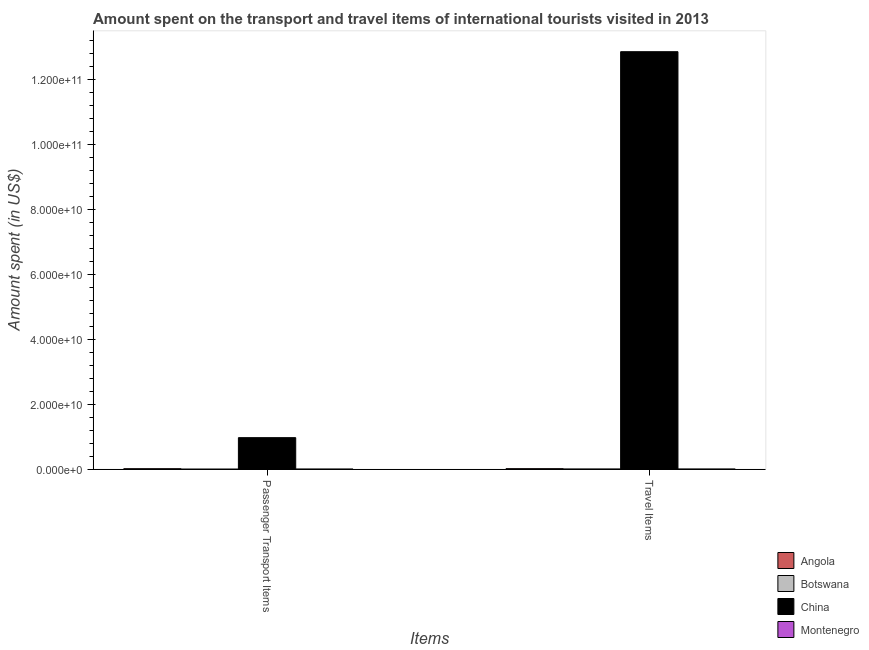How many different coloured bars are there?
Your answer should be compact. 4. Are the number of bars per tick equal to the number of legend labels?
Offer a very short reply. Yes. What is the label of the 2nd group of bars from the left?
Provide a short and direct response. Travel Items. What is the amount spent on passenger transport items in China?
Your response must be concise. 9.72e+09. Across all countries, what is the maximum amount spent on passenger transport items?
Offer a very short reply. 9.72e+09. Across all countries, what is the minimum amount spent in travel items?
Offer a terse response. 4.70e+07. In which country was the amount spent on passenger transport items minimum?
Your answer should be compact. Botswana. What is the total amount spent in travel items in the graph?
Your answer should be very brief. 1.29e+11. What is the difference between the amount spent on passenger transport items in China and that in Angola?
Give a very brief answer. 9.57e+09. What is the difference between the amount spent on passenger transport items in Montenegro and the amount spent in travel items in China?
Your answer should be compact. -1.29e+11. What is the average amount spent on passenger transport items per country?
Give a very brief answer. 2.48e+09. What is the difference between the amount spent on passenger transport items and amount spent in travel items in China?
Your answer should be very brief. -1.19e+11. What is the ratio of the amount spent on passenger transport items in China to that in Botswana?
Offer a terse response. 4.86e+04. Is the amount spent on passenger transport items in Botswana less than that in Montenegro?
Provide a short and direct response. Yes. What does the 4th bar from the left in Travel Items represents?
Your answer should be very brief. Montenegro. What does the 1st bar from the right in Passenger Transport Items represents?
Your response must be concise. Montenegro. How many bars are there?
Your answer should be compact. 8. Are all the bars in the graph horizontal?
Ensure brevity in your answer.  No. What is the difference between two consecutive major ticks on the Y-axis?
Provide a succinct answer. 2.00e+1. Does the graph contain any zero values?
Provide a short and direct response. No. How are the legend labels stacked?
Provide a short and direct response. Vertical. What is the title of the graph?
Your answer should be very brief. Amount spent on the transport and travel items of international tourists visited in 2013. What is the label or title of the X-axis?
Ensure brevity in your answer.  Items. What is the label or title of the Y-axis?
Give a very brief answer. Amount spent (in US$). What is the Amount spent (in US$) in Angola in Passenger Transport Items?
Your answer should be compact. 1.53e+08. What is the Amount spent (in US$) of Botswana in Passenger Transport Items?
Offer a terse response. 2.00e+05. What is the Amount spent (in US$) in China in Passenger Transport Items?
Your response must be concise. 9.72e+09. What is the Amount spent (in US$) in Montenegro in Passenger Transport Items?
Ensure brevity in your answer.  3.30e+07. What is the Amount spent (in US$) of Angola in Travel Items?
Make the answer very short. 1.66e+08. What is the Amount spent (in US$) in Botswana in Travel Items?
Offer a terse response. 4.70e+07. What is the Amount spent (in US$) in China in Travel Items?
Offer a terse response. 1.29e+11. What is the Amount spent (in US$) in Montenegro in Travel Items?
Keep it short and to the point. 4.80e+07. Across all Items, what is the maximum Amount spent (in US$) in Angola?
Your answer should be compact. 1.66e+08. Across all Items, what is the maximum Amount spent (in US$) in Botswana?
Give a very brief answer. 4.70e+07. Across all Items, what is the maximum Amount spent (in US$) in China?
Offer a very short reply. 1.29e+11. Across all Items, what is the maximum Amount spent (in US$) in Montenegro?
Provide a succinct answer. 4.80e+07. Across all Items, what is the minimum Amount spent (in US$) of Angola?
Ensure brevity in your answer.  1.53e+08. Across all Items, what is the minimum Amount spent (in US$) of Botswana?
Provide a short and direct response. 2.00e+05. Across all Items, what is the minimum Amount spent (in US$) in China?
Offer a terse response. 9.72e+09. Across all Items, what is the minimum Amount spent (in US$) in Montenegro?
Keep it short and to the point. 3.30e+07. What is the total Amount spent (in US$) of Angola in the graph?
Give a very brief answer. 3.19e+08. What is the total Amount spent (in US$) in Botswana in the graph?
Offer a very short reply. 4.72e+07. What is the total Amount spent (in US$) of China in the graph?
Give a very brief answer. 1.38e+11. What is the total Amount spent (in US$) of Montenegro in the graph?
Provide a succinct answer. 8.10e+07. What is the difference between the Amount spent (in US$) of Angola in Passenger Transport Items and that in Travel Items?
Offer a very short reply. -1.30e+07. What is the difference between the Amount spent (in US$) in Botswana in Passenger Transport Items and that in Travel Items?
Keep it short and to the point. -4.68e+07. What is the difference between the Amount spent (in US$) of China in Passenger Transport Items and that in Travel Items?
Ensure brevity in your answer.  -1.19e+11. What is the difference between the Amount spent (in US$) of Montenegro in Passenger Transport Items and that in Travel Items?
Offer a terse response. -1.50e+07. What is the difference between the Amount spent (in US$) in Angola in Passenger Transport Items and the Amount spent (in US$) in Botswana in Travel Items?
Give a very brief answer. 1.06e+08. What is the difference between the Amount spent (in US$) of Angola in Passenger Transport Items and the Amount spent (in US$) of China in Travel Items?
Make the answer very short. -1.28e+11. What is the difference between the Amount spent (in US$) of Angola in Passenger Transport Items and the Amount spent (in US$) of Montenegro in Travel Items?
Offer a very short reply. 1.05e+08. What is the difference between the Amount spent (in US$) of Botswana in Passenger Transport Items and the Amount spent (in US$) of China in Travel Items?
Ensure brevity in your answer.  -1.29e+11. What is the difference between the Amount spent (in US$) of Botswana in Passenger Transport Items and the Amount spent (in US$) of Montenegro in Travel Items?
Offer a very short reply. -4.78e+07. What is the difference between the Amount spent (in US$) of China in Passenger Transport Items and the Amount spent (in US$) of Montenegro in Travel Items?
Your response must be concise. 9.67e+09. What is the average Amount spent (in US$) of Angola per Items?
Your response must be concise. 1.60e+08. What is the average Amount spent (in US$) in Botswana per Items?
Offer a very short reply. 2.36e+07. What is the average Amount spent (in US$) in China per Items?
Make the answer very short. 6.91e+1. What is the average Amount spent (in US$) in Montenegro per Items?
Offer a terse response. 4.05e+07. What is the difference between the Amount spent (in US$) of Angola and Amount spent (in US$) of Botswana in Passenger Transport Items?
Offer a terse response. 1.53e+08. What is the difference between the Amount spent (in US$) of Angola and Amount spent (in US$) of China in Passenger Transport Items?
Ensure brevity in your answer.  -9.57e+09. What is the difference between the Amount spent (in US$) in Angola and Amount spent (in US$) in Montenegro in Passenger Transport Items?
Offer a very short reply. 1.20e+08. What is the difference between the Amount spent (in US$) in Botswana and Amount spent (in US$) in China in Passenger Transport Items?
Provide a succinct answer. -9.72e+09. What is the difference between the Amount spent (in US$) of Botswana and Amount spent (in US$) of Montenegro in Passenger Transport Items?
Give a very brief answer. -3.28e+07. What is the difference between the Amount spent (in US$) of China and Amount spent (in US$) of Montenegro in Passenger Transport Items?
Provide a succinct answer. 9.69e+09. What is the difference between the Amount spent (in US$) of Angola and Amount spent (in US$) of Botswana in Travel Items?
Offer a terse response. 1.19e+08. What is the difference between the Amount spent (in US$) in Angola and Amount spent (in US$) in China in Travel Items?
Provide a succinct answer. -1.28e+11. What is the difference between the Amount spent (in US$) of Angola and Amount spent (in US$) of Montenegro in Travel Items?
Your answer should be compact. 1.18e+08. What is the difference between the Amount spent (in US$) in Botswana and Amount spent (in US$) in China in Travel Items?
Make the answer very short. -1.29e+11. What is the difference between the Amount spent (in US$) in China and Amount spent (in US$) in Montenegro in Travel Items?
Provide a short and direct response. 1.29e+11. What is the ratio of the Amount spent (in US$) in Angola in Passenger Transport Items to that in Travel Items?
Give a very brief answer. 0.92. What is the ratio of the Amount spent (in US$) in Botswana in Passenger Transport Items to that in Travel Items?
Keep it short and to the point. 0. What is the ratio of the Amount spent (in US$) in China in Passenger Transport Items to that in Travel Items?
Your response must be concise. 0.08. What is the ratio of the Amount spent (in US$) of Montenegro in Passenger Transport Items to that in Travel Items?
Offer a terse response. 0.69. What is the difference between the highest and the second highest Amount spent (in US$) of Angola?
Your answer should be compact. 1.30e+07. What is the difference between the highest and the second highest Amount spent (in US$) in Botswana?
Your response must be concise. 4.68e+07. What is the difference between the highest and the second highest Amount spent (in US$) of China?
Provide a short and direct response. 1.19e+11. What is the difference between the highest and the second highest Amount spent (in US$) of Montenegro?
Your response must be concise. 1.50e+07. What is the difference between the highest and the lowest Amount spent (in US$) in Angola?
Provide a short and direct response. 1.30e+07. What is the difference between the highest and the lowest Amount spent (in US$) in Botswana?
Provide a short and direct response. 4.68e+07. What is the difference between the highest and the lowest Amount spent (in US$) in China?
Make the answer very short. 1.19e+11. What is the difference between the highest and the lowest Amount spent (in US$) in Montenegro?
Provide a succinct answer. 1.50e+07. 